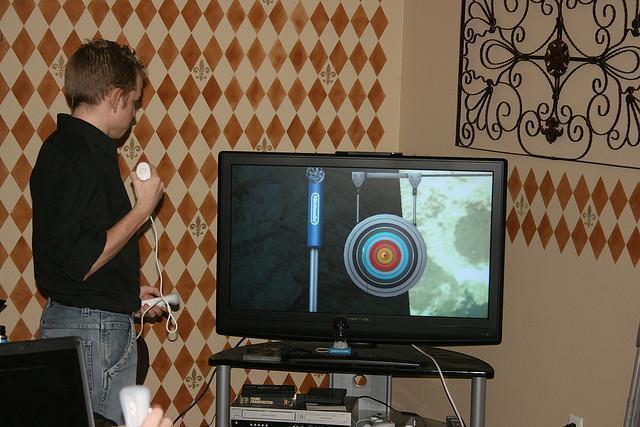How many tvs are in the picture?
Give a very brief answer. 1. 